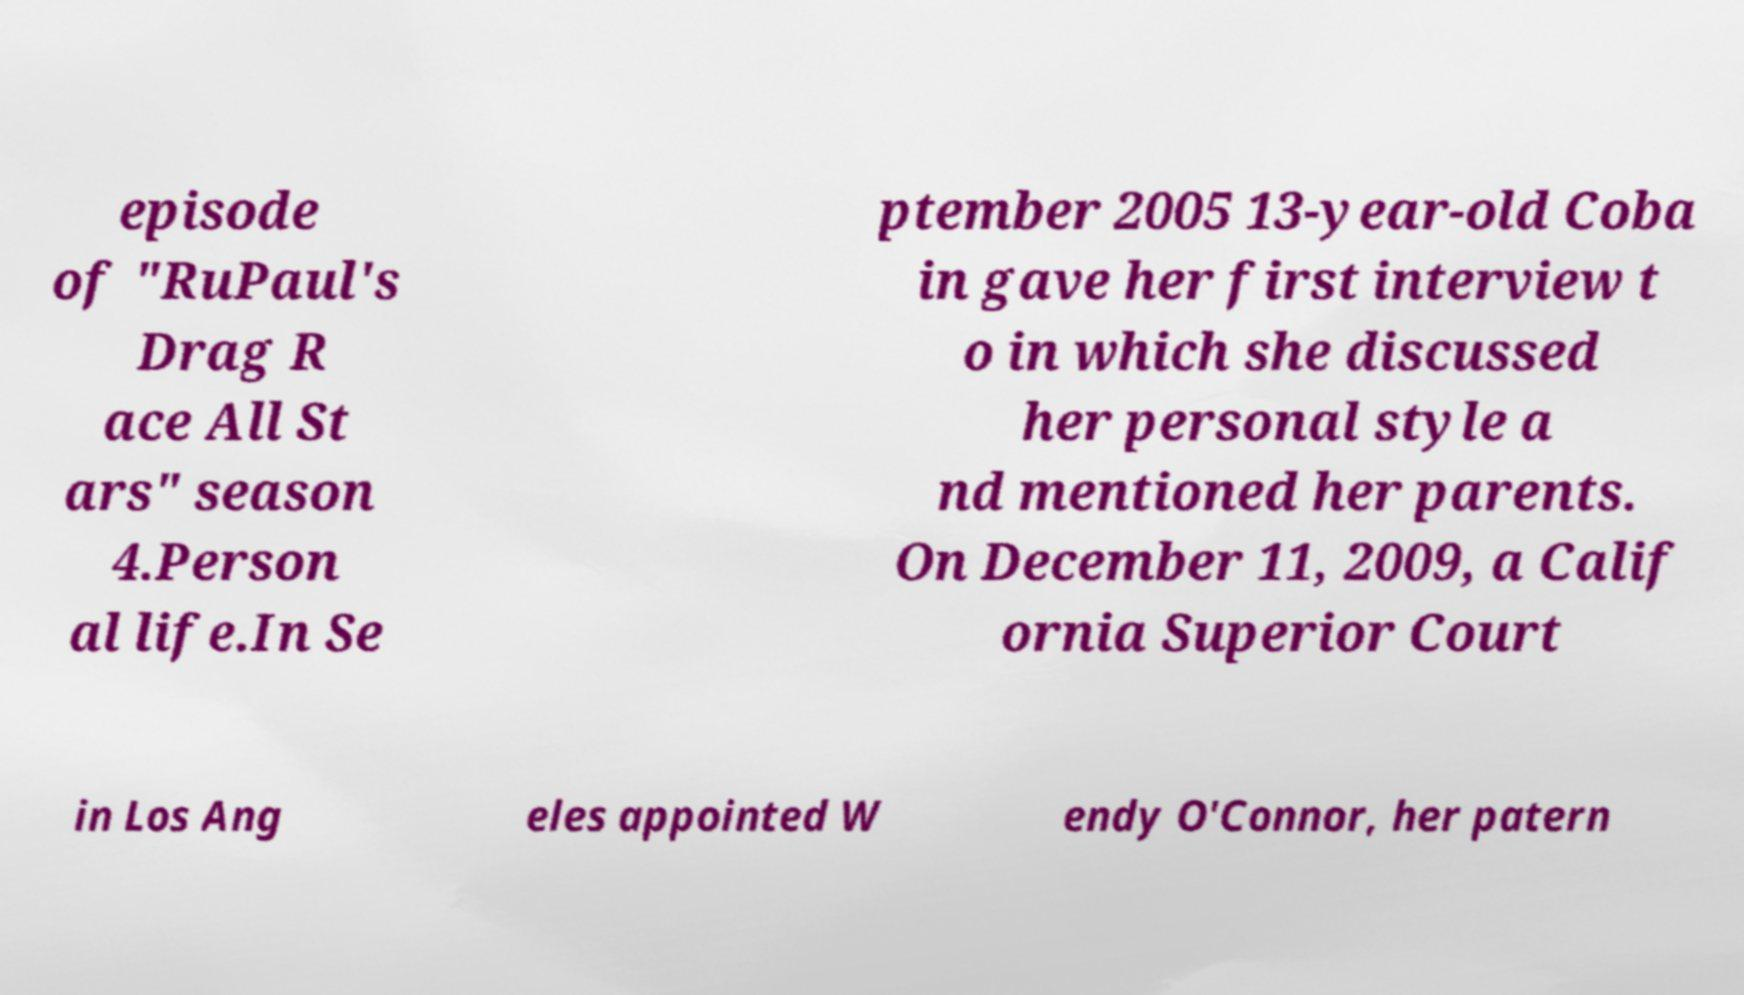Can you read and provide the text displayed in the image?This photo seems to have some interesting text. Can you extract and type it out for me? episode of "RuPaul's Drag R ace All St ars" season 4.Person al life.In Se ptember 2005 13-year-old Coba in gave her first interview t o in which she discussed her personal style a nd mentioned her parents. On December 11, 2009, a Calif ornia Superior Court in Los Ang eles appointed W endy O'Connor, her patern 